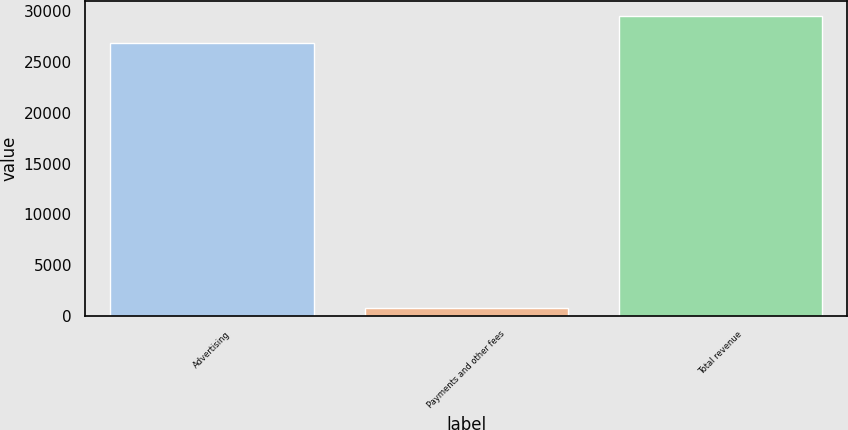<chart> <loc_0><loc_0><loc_500><loc_500><bar_chart><fcel>Advertising<fcel>Payments and other fees<fcel>Total revenue<nl><fcel>26885<fcel>753<fcel>29573.5<nl></chart> 